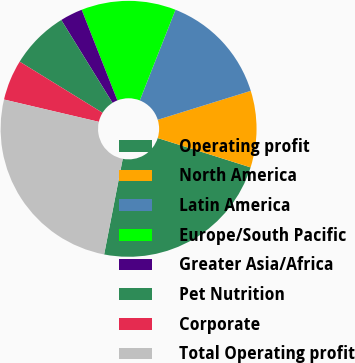<chart> <loc_0><loc_0><loc_500><loc_500><pie_chart><fcel>Operating profit<fcel>North America<fcel>Latin America<fcel>Europe/South Pacific<fcel>Greater Asia/Africa<fcel>Pet Nutrition<fcel>Corporate<fcel>Total Operating profit<nl><fcel>23.19%<fcel>9.67%<fcel>14.23%<fcel>11.95%<fcel>2.84%<fcel>7.39%<fcel>5.12%<fcel>25.62%<nl></chart> 